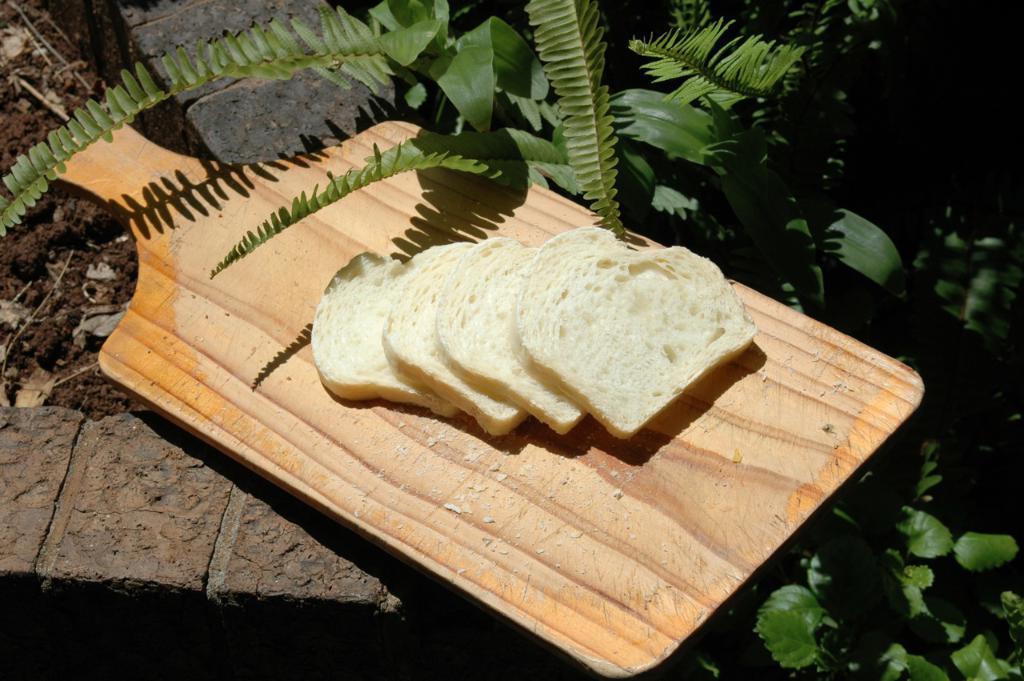Please provide a concise description of this image. In this picture we can observe some pieces of bread placed on the brown color plate. There are some plants. We can observe mud on the left side. 